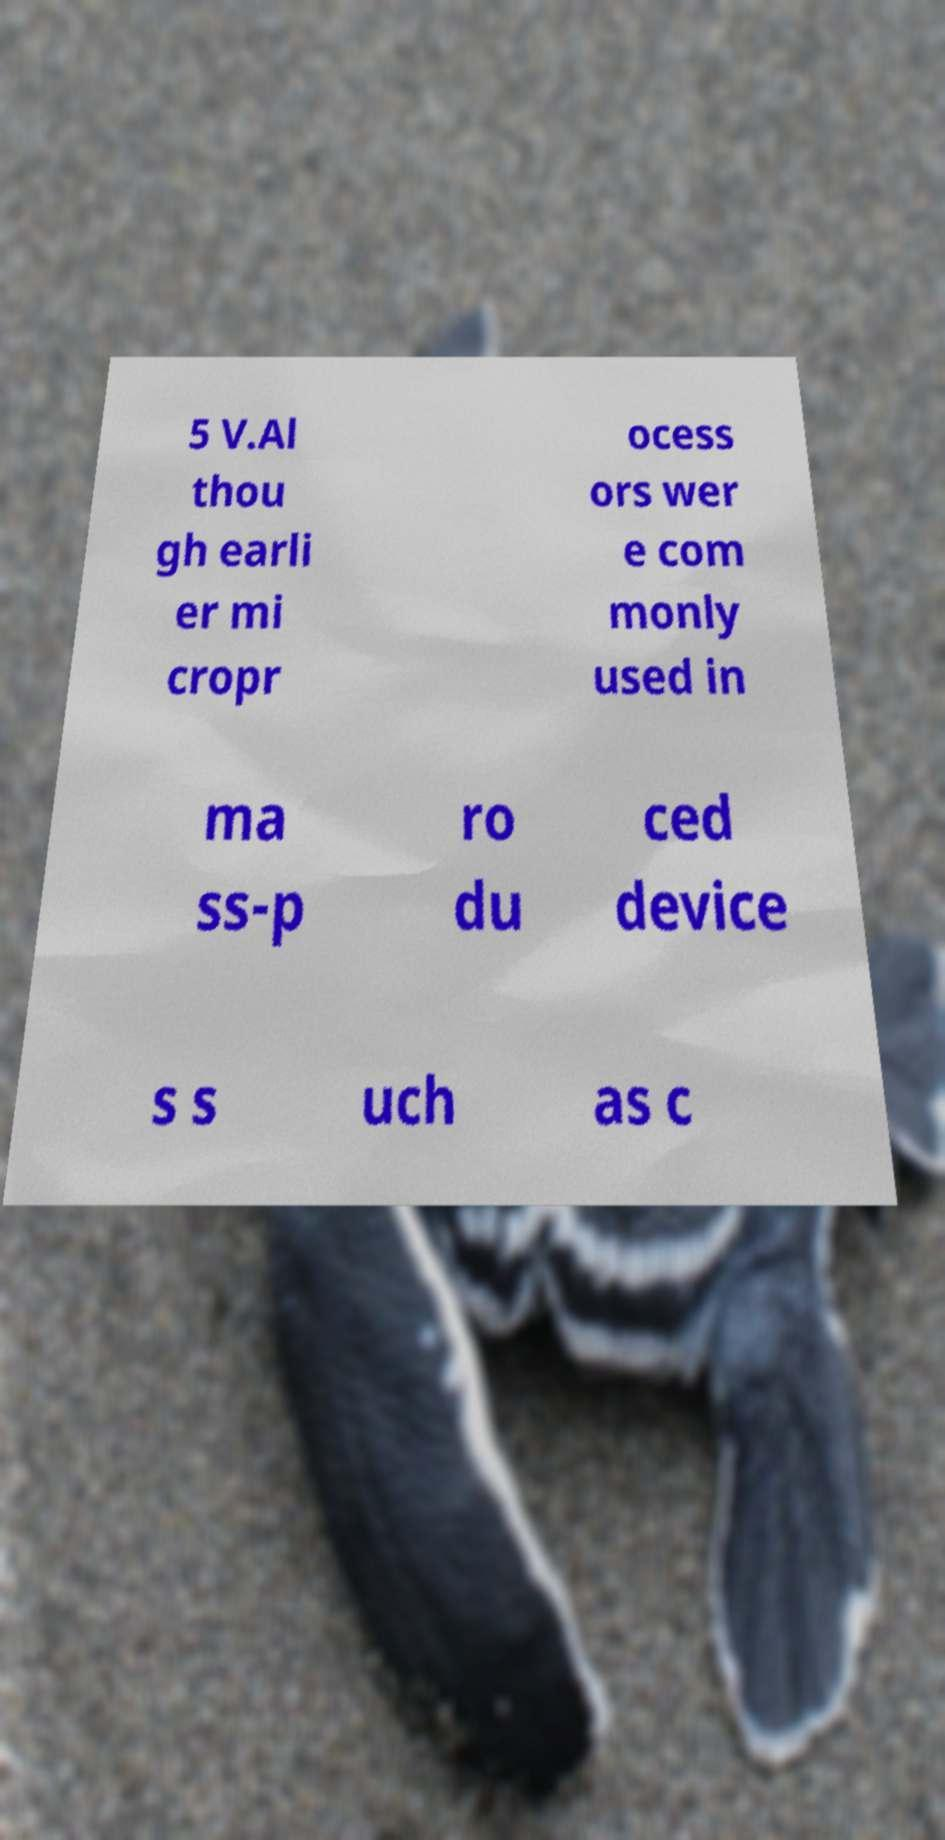I need the written content from this picture converted into text. Can you do that? 5 V.Al thou gh earli er mi cropr ocess ors wer e com monly used in ma ss-p ro du ced device s s uch as c 